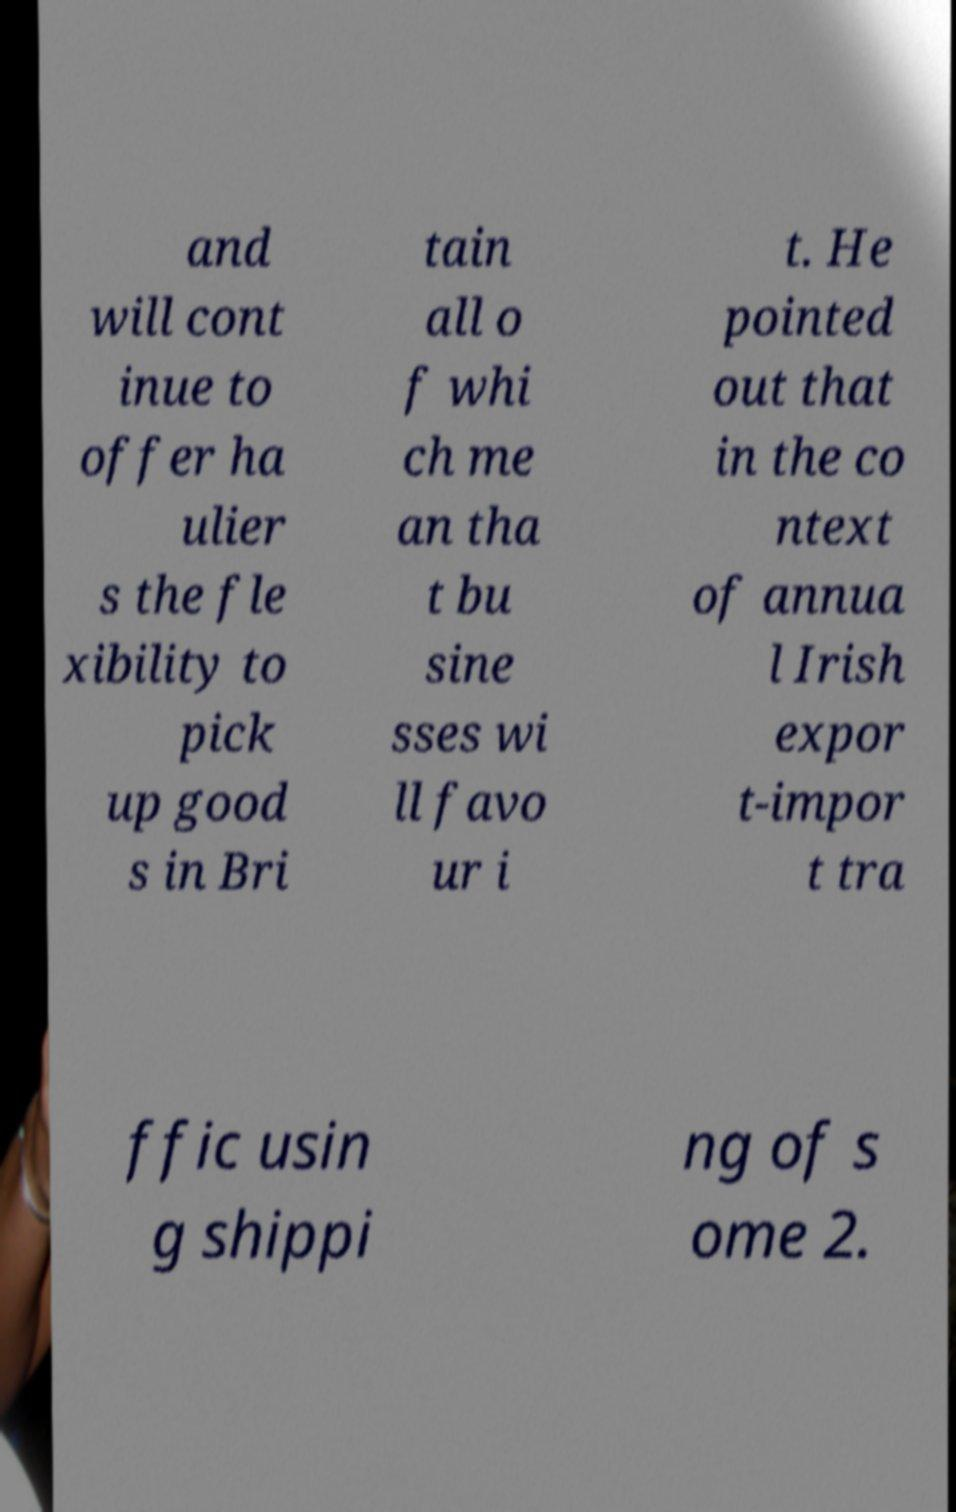What messages or text are displayed in this image? I need them in a readable, typed format. and will cont inue to offer ha ulier s the fle xibility to pick up good s in Bri tain all o f whi ch me an tha t bu sine sses wi ll favo ur i t. He pointed out that in the co ntext of annua l Irish expor t-impor t tra ffic usin g shippi ng of s ome 2. 